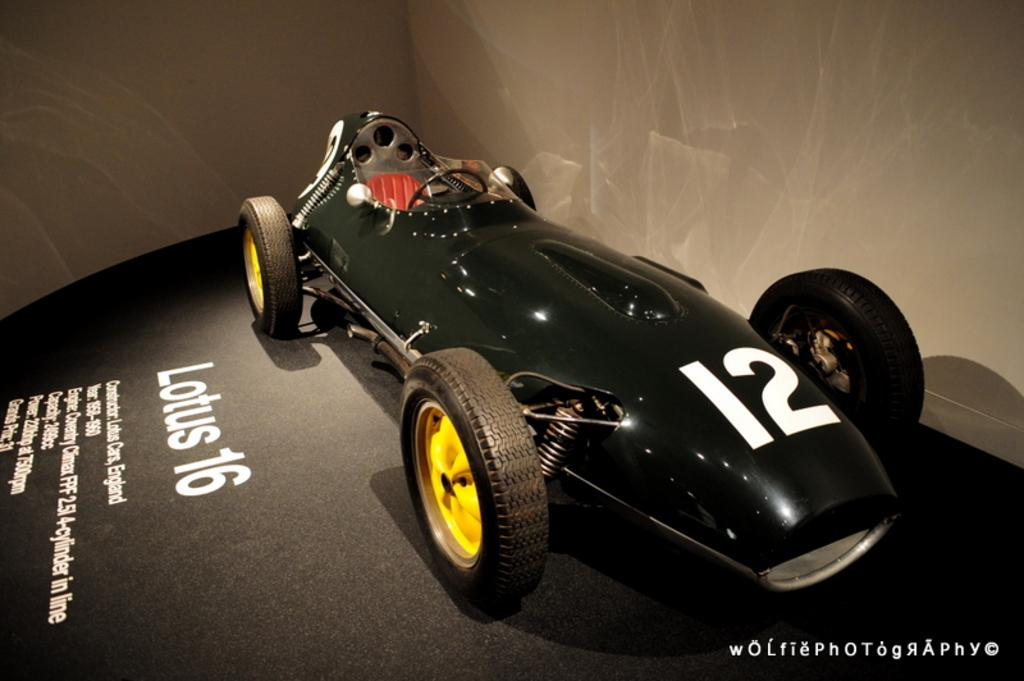What object is placed on the floor in the image? There is a vehicle on the floor in the image. What is located beside the vehicle? There is text beside the vehicle. What can be seen on the right side of the image? There is a wall on the right side of the image. What is visible in the background of the image? There is a wall visible in the background of the image. What type of brush is being used to test the advertisement in the image? There is no brush, test, or advertisement present in the image. 